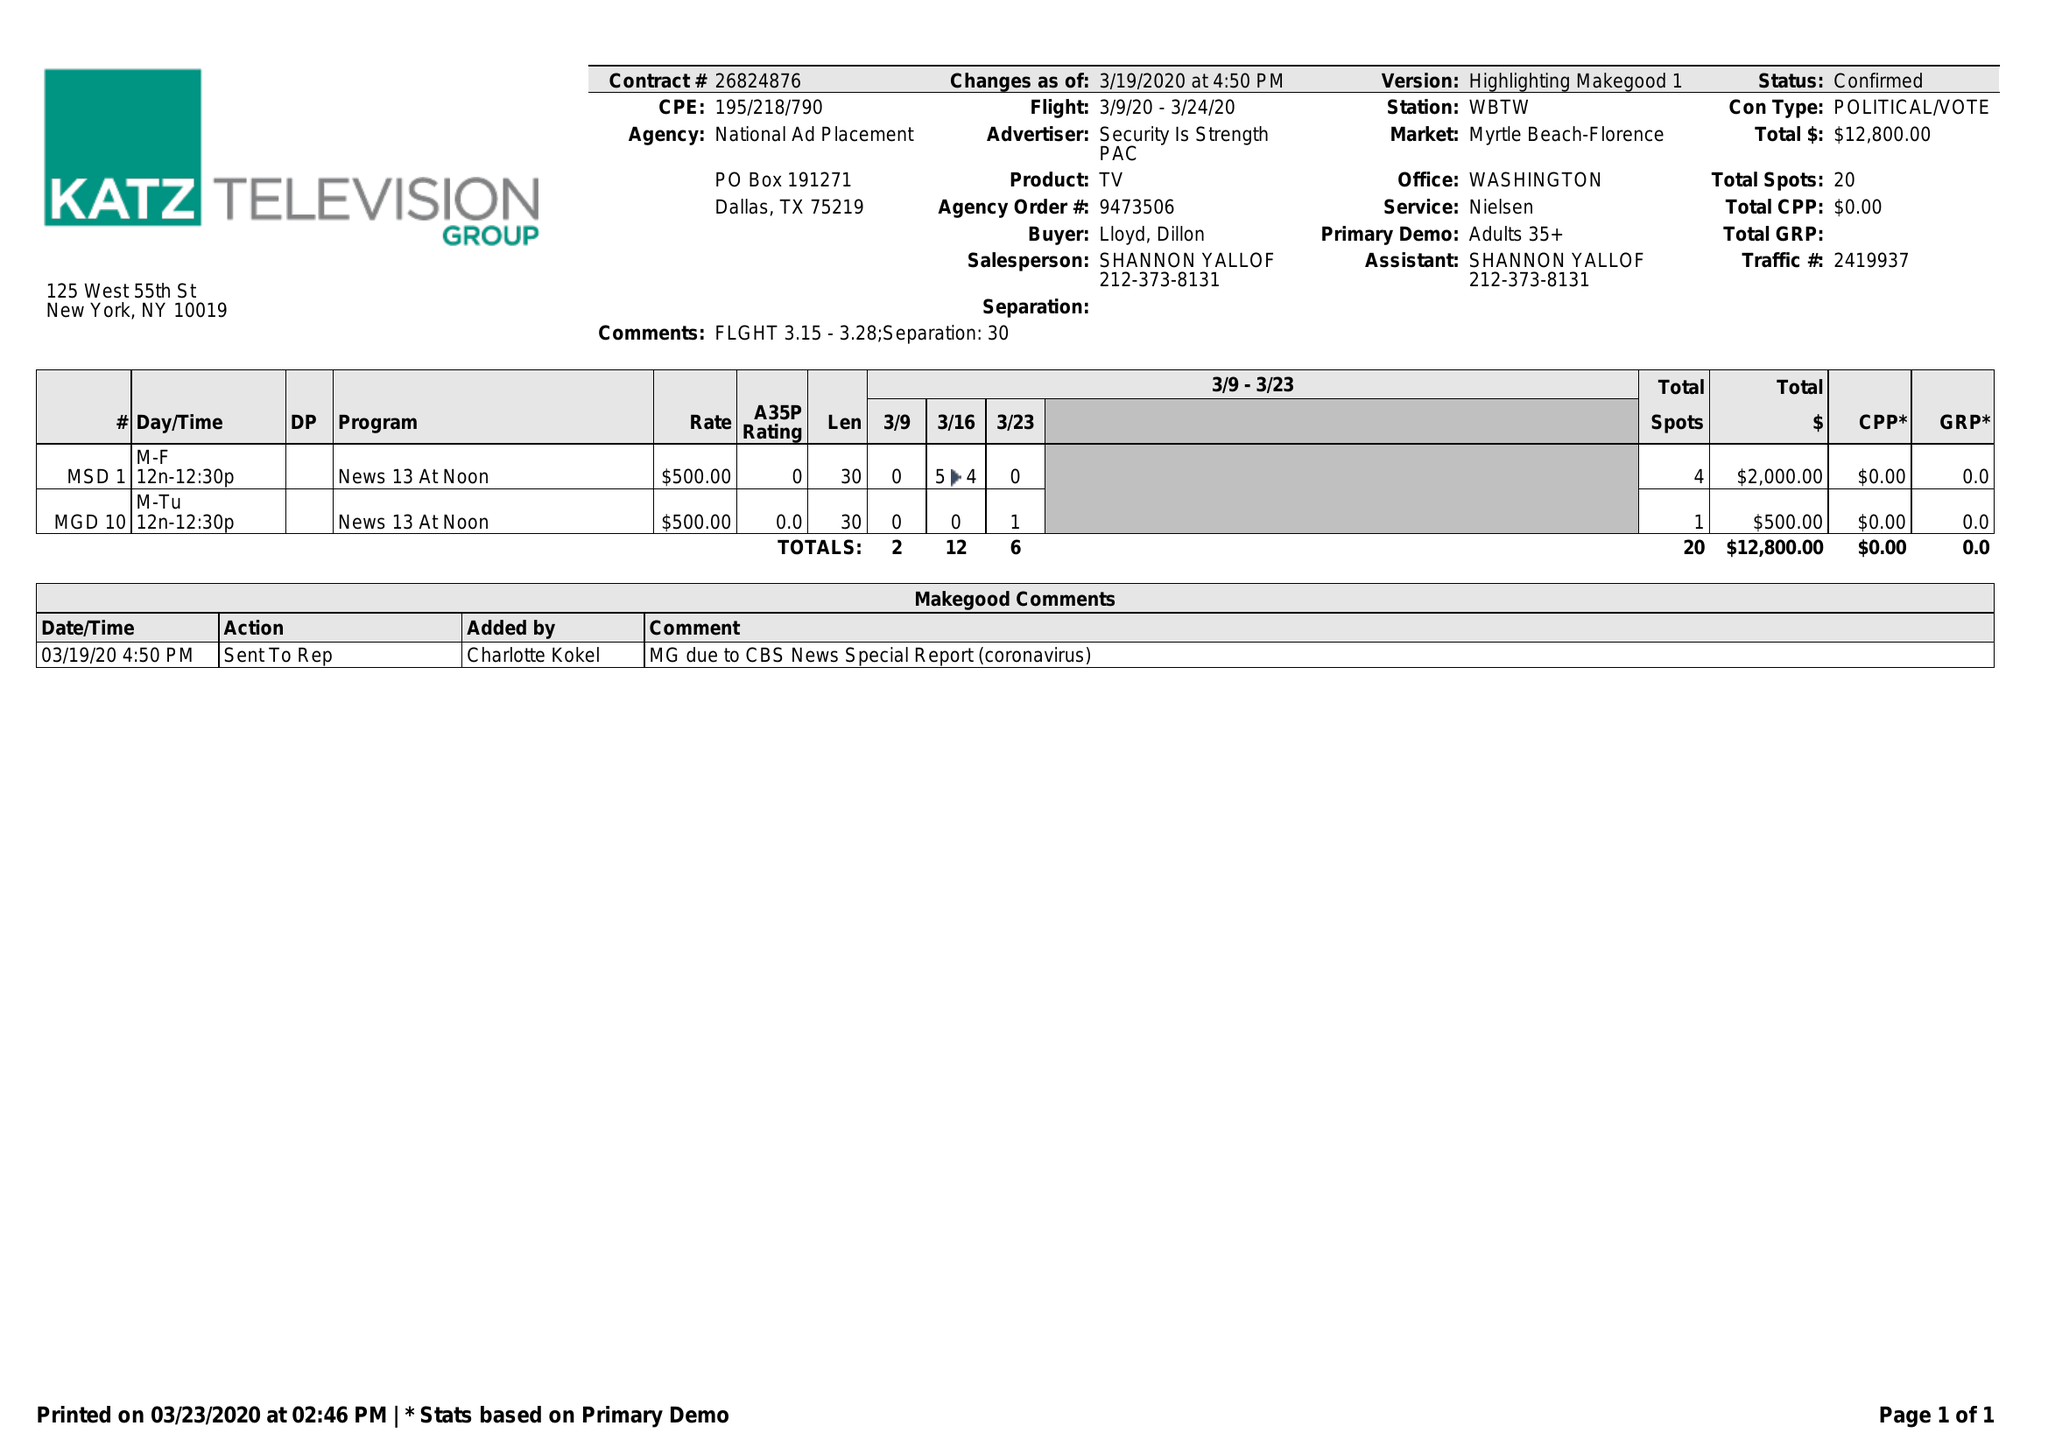What is the value for the advertiser?
Answer the question using a single word or phrase. SECURITY IS STRENGTH PAC 